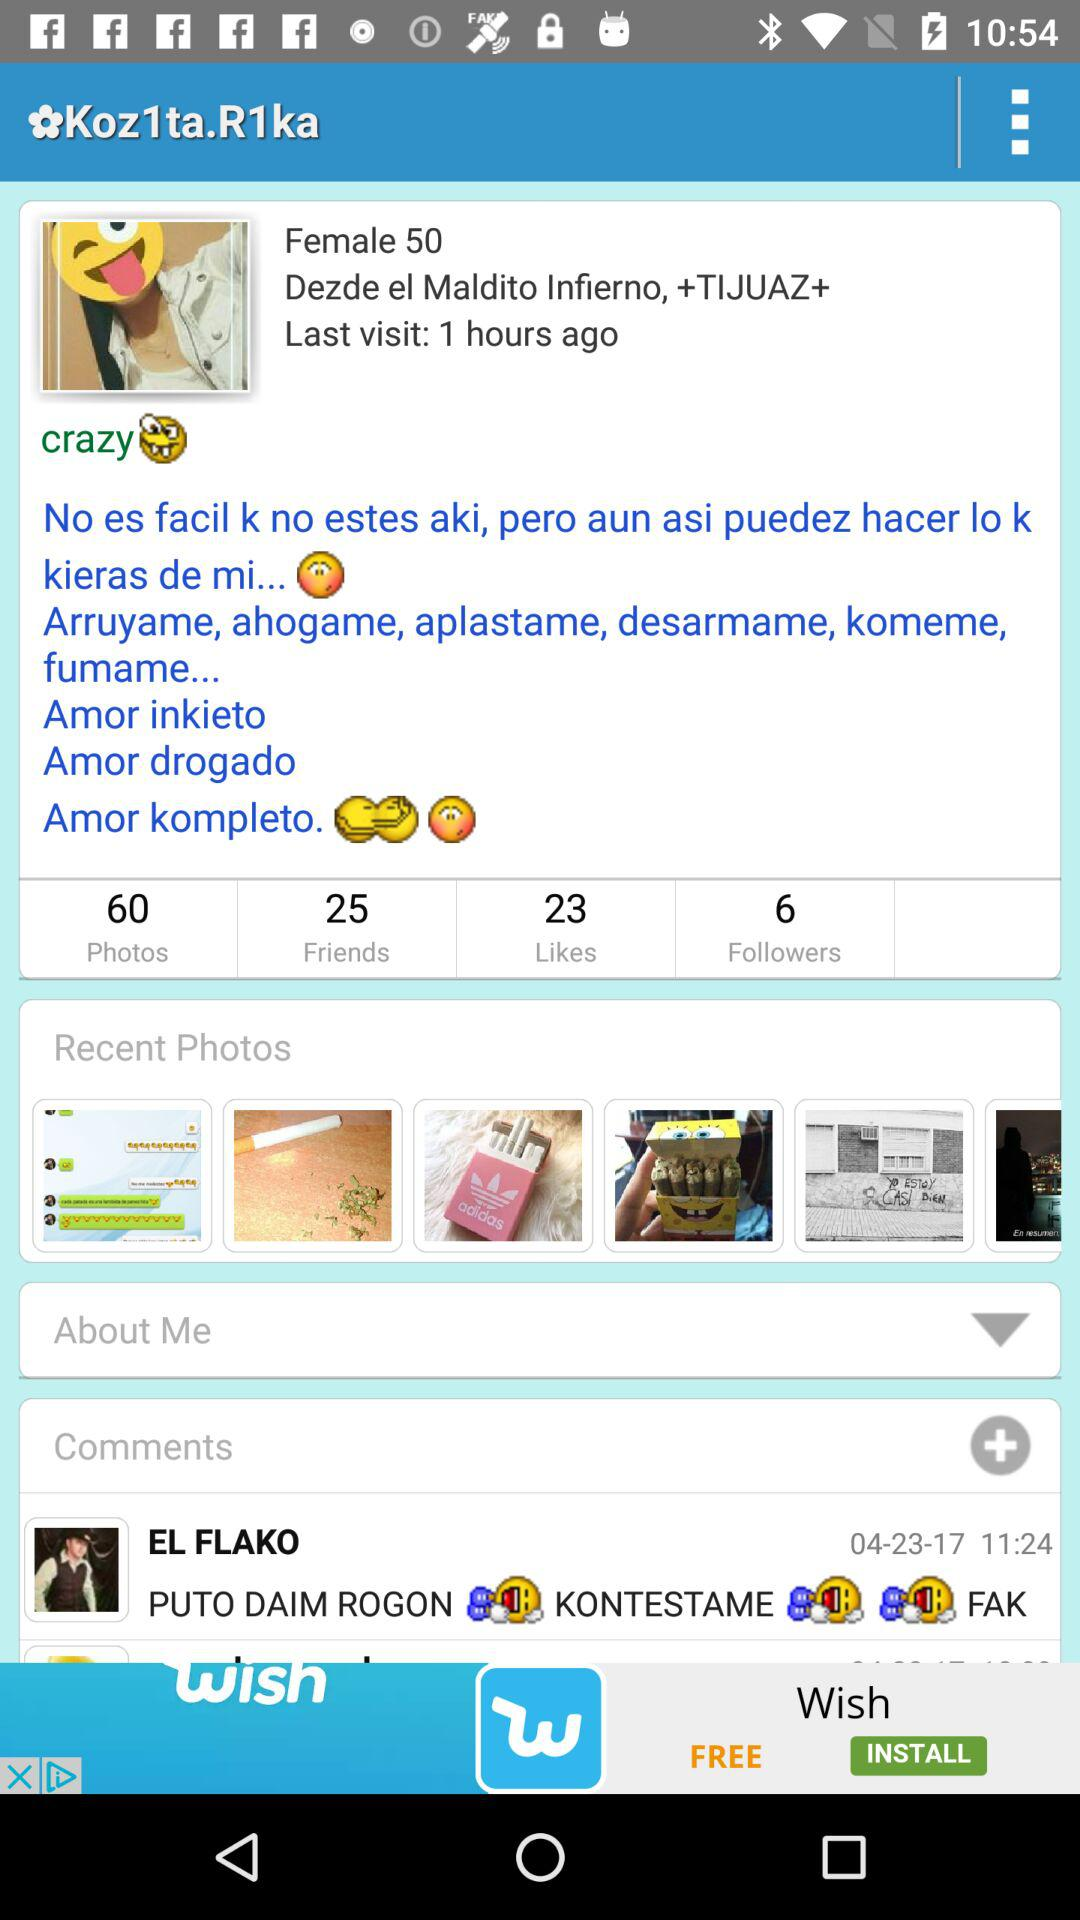When was the last visit? The last visit was 1 hour ago. 